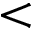Convert formula to latex. <formula><loc_0><loc_0><loc_500><loc_500><</formula> 